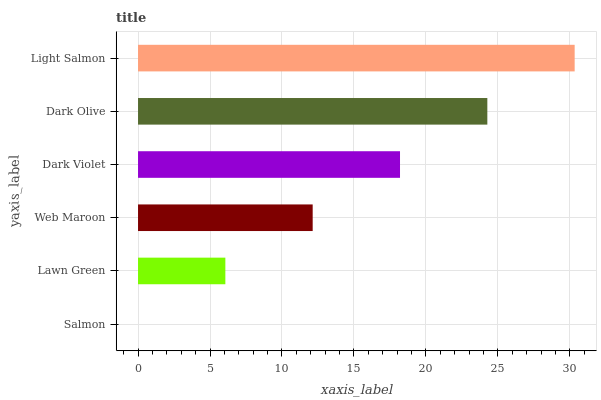Is Salmon the minimum?
Answer yes or no. Yes. Is Light Salmon the maximum?
Answer yes or no. Yes. Is Lawn Green the minimum?
Answer yes or no. No. Is Lawn Green the maximum?
Answer yes or no. No. Is Lawn Green greater than Salmon?
Answer yes or no. Yes. Is Salmon less than Lawn Green?
Answer yes or no. Yes. Is Salmon greater than Lawn Green?
Answer yes or no. No. Is Lawn Green less than Salmon?
Answer yes or no. No. Is Dark Violet the high median?
Answer yes or no. Yes. Is Web Maroon the low median?
Answer yes or no. Yes. Is Lawn Green the high median?
Answer yes or no. No. Is Light Salmon the low median?
Answer yes or no. No. 